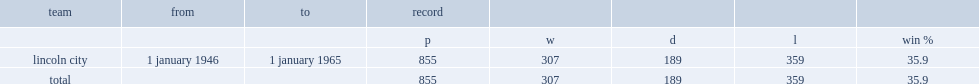How many games did anderson depart in 1965 after managing games? 855.0. 